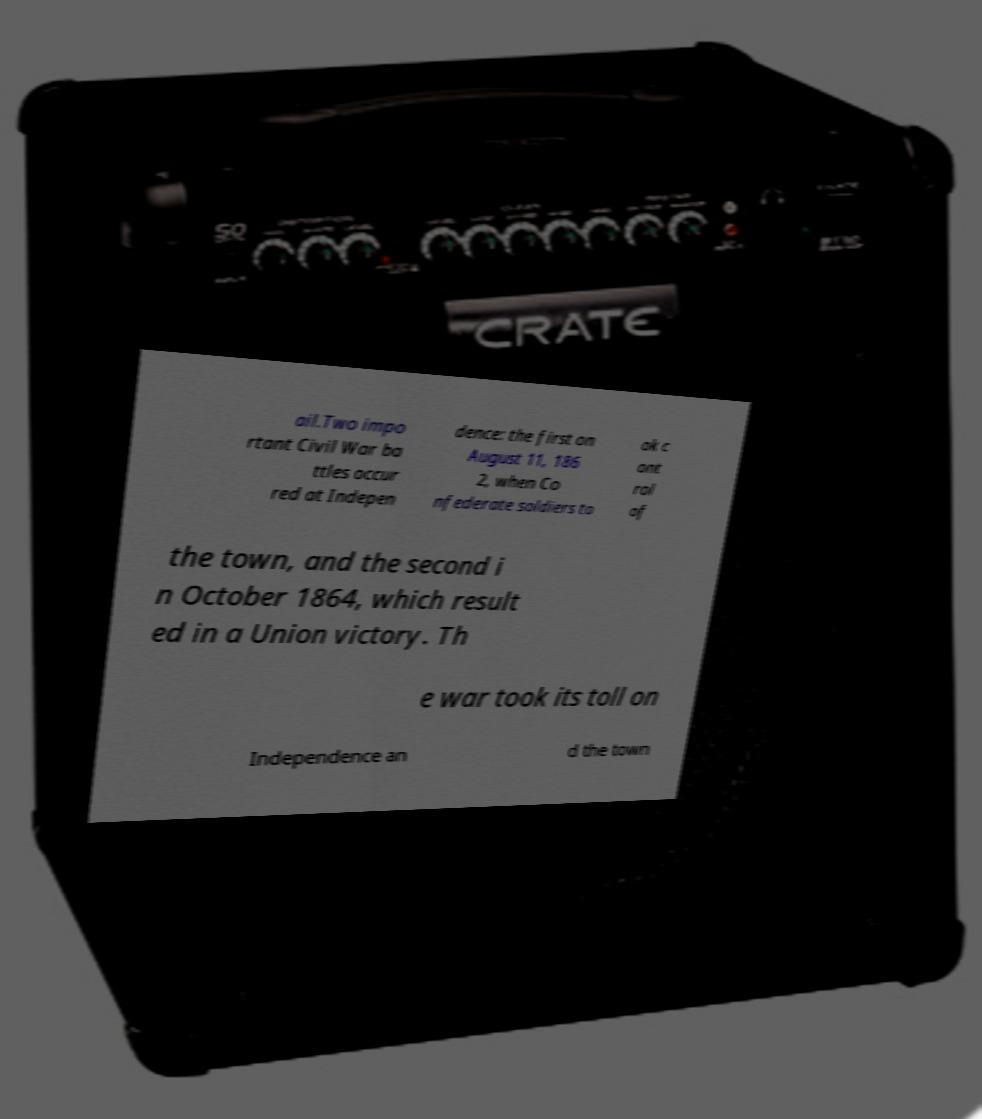What messages or text are displayed in this image? I need them in a readable, typed format. ail.Two impo rtant Civil War ba ttles occur red at Indepen dence: the first on August 11, 186 2, when Co nfederate soldiers to ok c ont rol of the town, and the second i n October 1864, which result ed in a Union victory. Th e war took its toll on Independence an d the town 